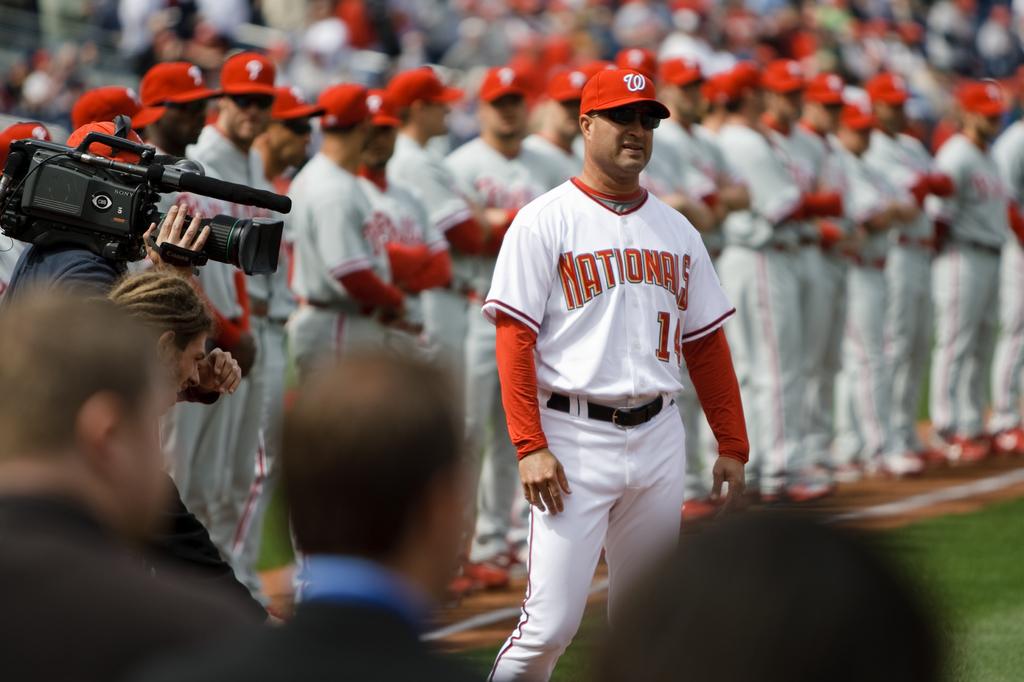What is the mans jersey number?
Keep it short and to the point. 14. 